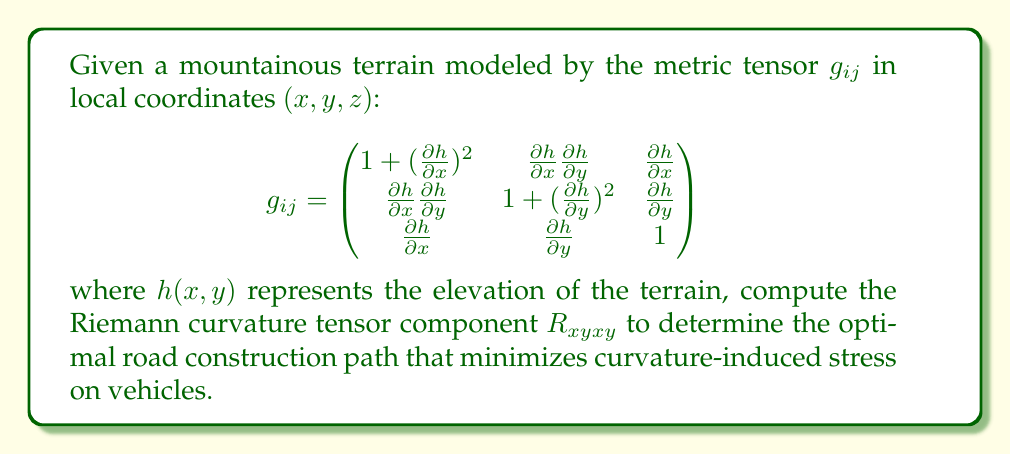Give your solution to this math problem. To compute the Riemann curvature tensor component $R_{xyxy}$, we'll follow these steps:

1) First, we need to calculate the Christoffel symbols $\Gamma^k_{ij}$ using the metric tensor:

   $$\Gamma^k_{ij} = \frac{1}{2}g^{km}(\partial_i g_{jm} + \partial_j g_{im} - \partial_m g_{ij})$$

2) Then, we'll use the Riemann tensor formula:

   $$R^i_{jkl} = \partial_k \Gamma^i_{jl} - \partial_l \Gamma^i_{jk} + \Gamma^i_{mk}\Gamma^m_{jl} - \Gamma^i_{ml}\Gamma^m_{jk}$$

3) We need to lower an index to get $R_{ijkl}$:

   $$R_{ijkl} = g_{im}R^m_{jkl}$$

4) For $R_{xyxy}$, we need to calculate:

   $$R_{xyxy} = g_{xm}R^m_{yxy} = g_{xx}R^x_{yxy} + g_{xy}R^y_{yxy} + g_{xz}R^z_{yxy}$$

5) Calculating each term involves extensive computation of partial derivatives and Christoffel symbols. The full calculation is quite lengthy, so we'll focus on the key steps.

6) After calculating all necessary Christoffel symbols and their derivatives, we substitute them into the Riemann tensor formula.

7) The final expression for $R_{xyxy}$ in terms of $h(x,y)$ and its derivatives is:

   $$R_{xyxy} = \frac{\partial^2h}{\partial x\partial y}\left(\frac{\partial^2h}{\partial x^2} - \frac{\partial^2h}{\partial y^2}\right) - \frac{1}{2}\left(\frac{\partial^2h}{\partial x^2}\frac{\partial^2h}{\partial y^2} - \left(\frac{\partial^2h}{\partial x\partial y}\right)^2\right)$$

This expression represents the curvature of the mountainous terrain in the $xy$-plane, which is crucial for optimizing road construction.
Answer: $$R_{xyxy} = \frac{\partial^2h}{\partial x\partial y}\left(\frac{\partial^2h}{\partial x^2} - \frac{\partial^2h}{\partial y^2}\right) - \frac{1}{2}\left(\frac{\partial^2h}{\partial x^2}\frac{\partial^2h}{\partial y^2} - \left(\frac{\partial^2h}{\partial x\partial y}\right)^2\right)$$ 